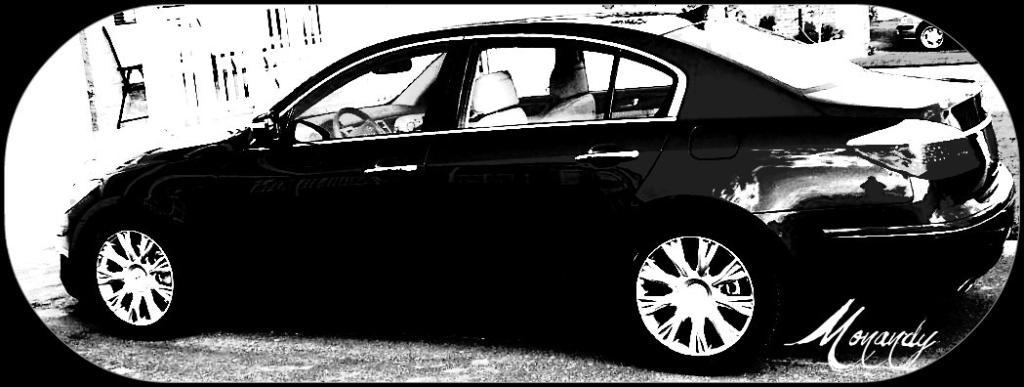What is the main subject of the image? The main subject of the image is a car. Are there any words or letters on the car? Yes, there is text on the car. What is the color scheme of the image? The image is black and white. Is there a toy car sliding down a slope in the image? No, there is no toy car or slope present in the image. The image features a real car with text on it, and the color scheme is black and white. 